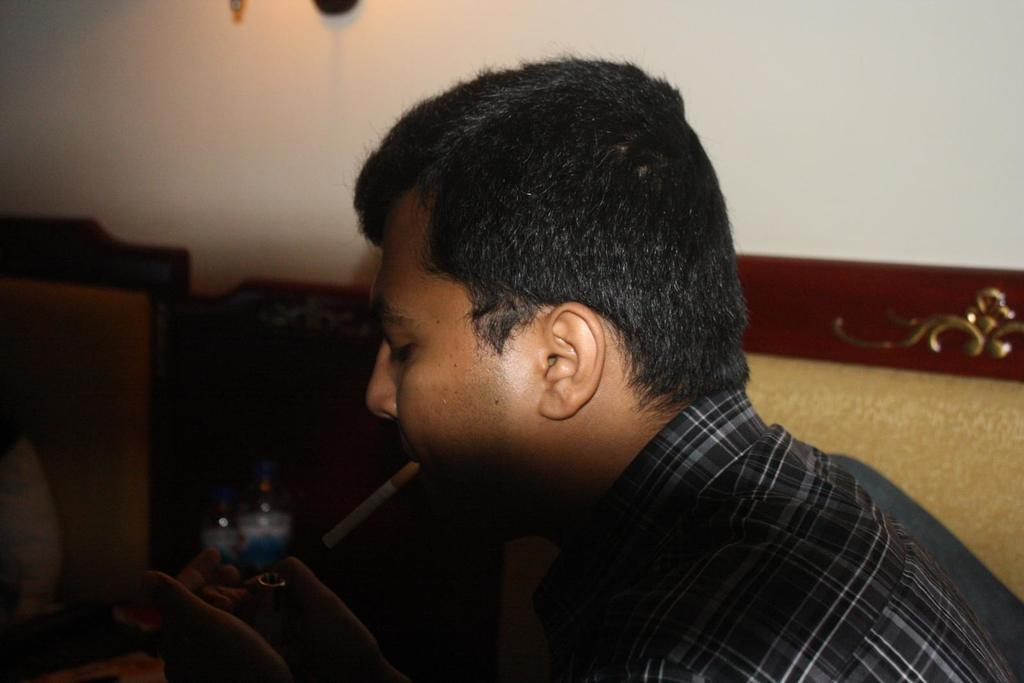What is the man in the image holding? The man is holding a cigarette in the image. What else can be seen in the image besides the man? There is a bottle in the image. What is the man wearing? The man is wearing a shirt in the image. Can you describe what the man is holding in his other hand? The man is holding something, but it is not specified in the facts provided. What type of wine is the man drinking in the image? There is no wine present in the image; the man is holding a cigarette and there is a bottle, but no wine is mentioned or visible. 